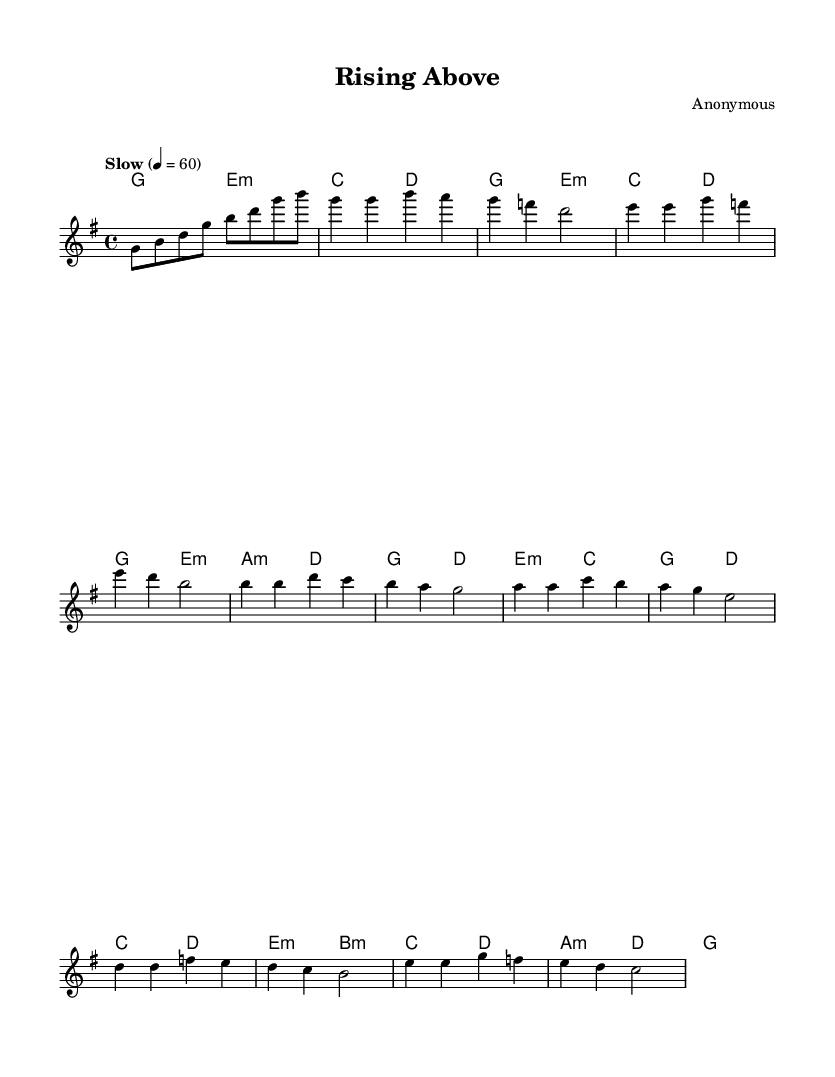What is the key signature of this music? The key signature is G major, which has one sharp (F#). This can be identified by looking at the beginning of the staff where the key signature is indicated.
Answer: G major What is the time signature of this piece? The time signature is 4/4, which indicates that there are four beats in each measure and a quarter note receives one beat. This is shown at the beginning of the sheet music.
Answer: 4/4 What is the tempo marking of this music? The tempo is marked as "Slow" with a metronome marking of 60 beats per minute, which can be seen at the beginning of the score.
Answer: Slow, 60 What chord precedes the first verse? The chord preceding the first verse is E minor, as indicated in the chord section right before the melody starts.
Answer: E minor How many measures are in the chorus? The chorus consists of four measures, which can be counted by looking at the section labeled "Chorus" and counting each measure indicated in the sheet music.
Answer: 4 What emotion does the bridge's lyrics convey? The bridge's lyrics convey a sense of empowerment and self-acceptance, as it speaks about embracing oneself without shame, reflecting the soul theme of overcoming challenges.
Answer: Empowerment What is the final chord of the piece? The final chord is G major, which is indicated at the end of the harmonies section. This suggests a resolution back to the home key.
Answer: G major 